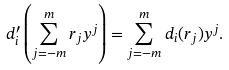Convert formula to latex. <formula><loc_0><loc_0><loc_500><loc_500>d ^ { \prime } _ { i } \left ( \sum _ { j = - m } ^ { m } r _ { j } y ^ { j } \right ) = \sum _ { j = - m } ^ { m } d _ { i } ( r _ { j } ) y ^ { j } .</formula> 